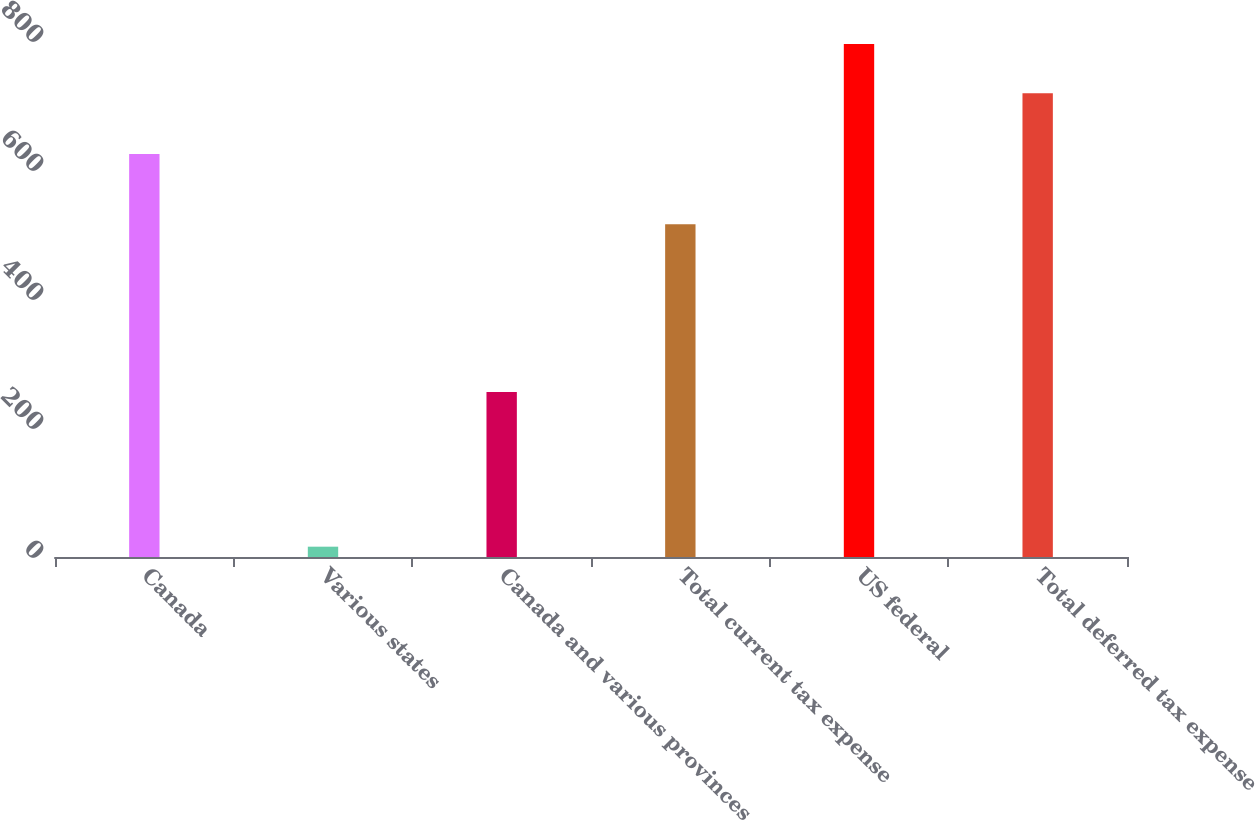<chart> <loc_0><loc_0><loc_500><loc_500><bar_chart><fcel>Canada<fcel>Various states<fcel>Canada and various provinces<fcel>Total current tax expense<fcel>US federal<fcel>Total deferred tax expense<nl><fcel>625<fcel>16<fcel>256<fcel>516<fcel>795.5<fcel>719<nl></chart> 